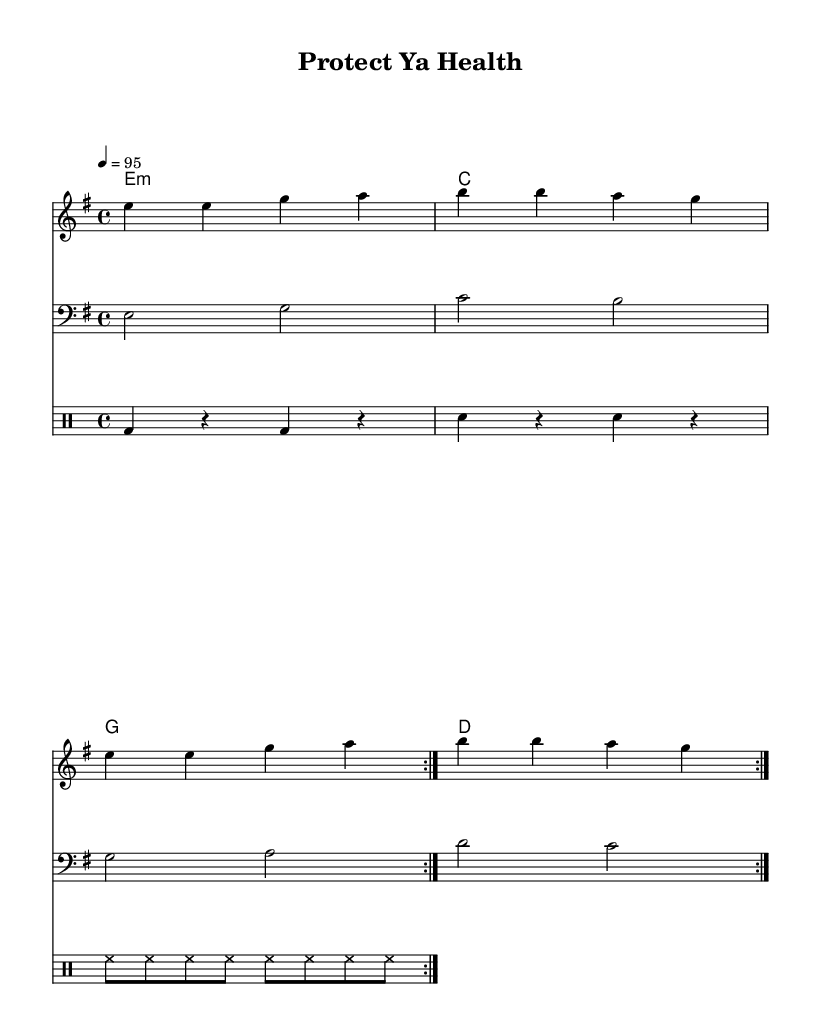What is the key signature of this music? The key signature is indicated at the beginning of the staff. In this case, it features one sharp, which identifies it as E minor.
Answer: E minor What is the time signature of this music? The time signature is shown at the beginning of the staff, which in this instance is 4/4, indicating four beats per measure.
Answer: 4/4 What is the tempo marking for this piece? The tempo marking provides the speed for the piece, indicated as 4 = 95, meaning it is set to 95 beats per minute.
Answer: 95 How many times is the melody repeated? The repeat signs in the score indicate the melody is played twice in succession, shown through the volta markings that are specified.
Answer: 2 What is the main theme of the chorus? The chorus conveys the importance of vaccination and protecting health, directly conveyed through lyrics that emphasize the need for vaccination.
Answer: Vaccination What type of music is this arrangement styled as? The rhythmic elements, lyrical themes, and setting suggest that this is a hip-hop piece, characterized by its upbeat and message-driven approach.
Answer: Hip hop What instruments are included in the score? The score contains a melody (likely sung or rapped), a bass line, harmonies, and a drum part, indicating a standard arrangement for a hip-hop track.
Answer: Melody, bass, drums 